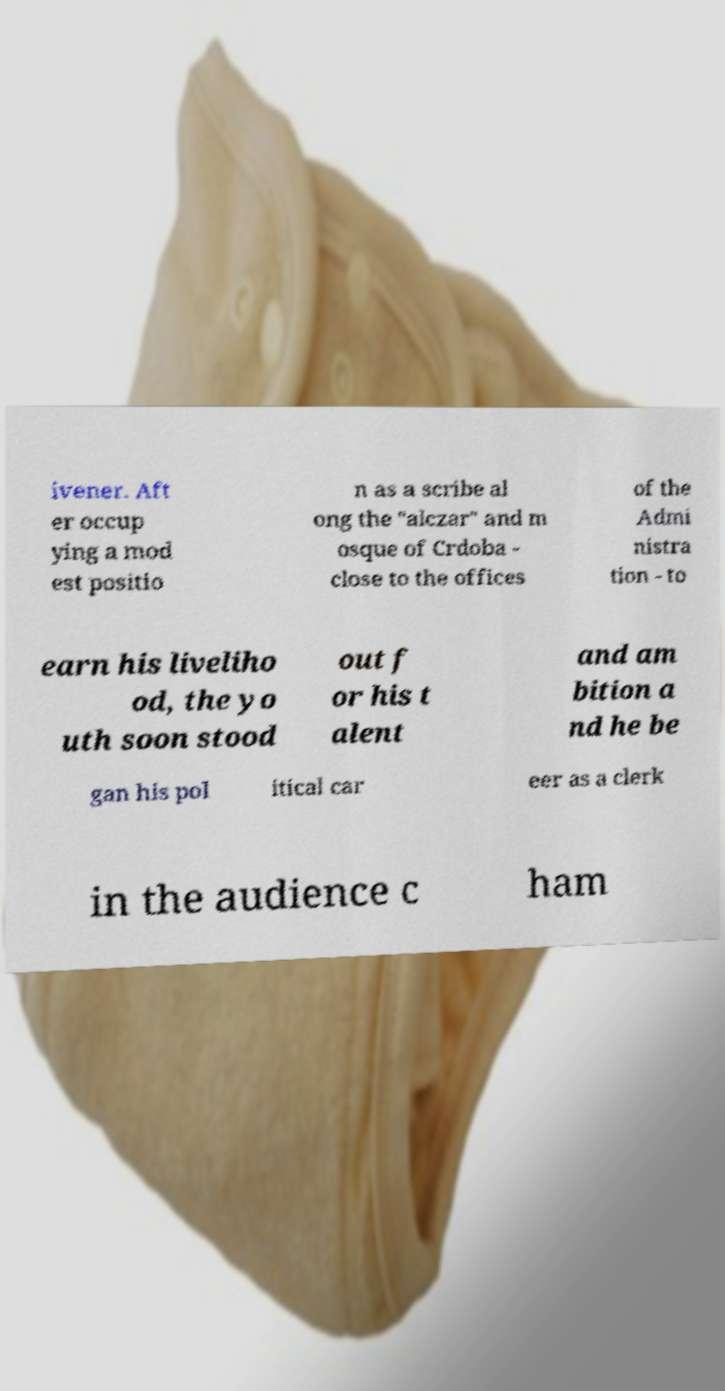Please identify and transcribe the text found in this image. ivener. Aft er occup ying a mod est positio n as a scribe al ong the "alczar" and m osque of Crdoba - close to the offices of the Admi nistra tion - to earn his liveliho od, the yo uth soon stood out f or his t alent and am bition a nd he be gan his pol itical car eer as a clerk in the audience c ham 